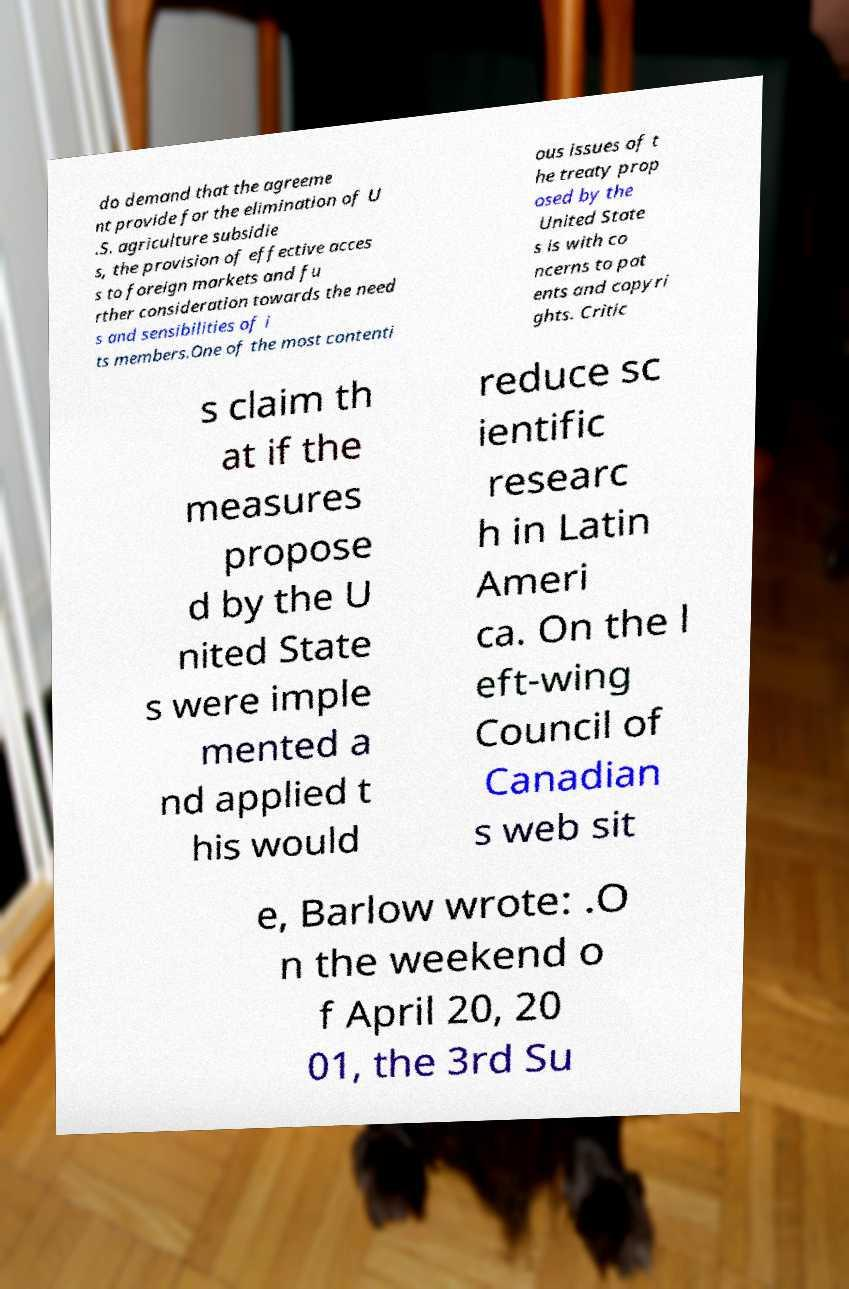Could you assist in decoding the text presented in this image and type it out clearly? do demand that the agreeme nt provide for the elimination of U .S. agriculture subsidie s, the provision of effective acces s to foreign markets and fu rther consideration towards the need s and sensibilities of i ts members.One of the most contenti ous issues of t he treaty prop osed by the United State s is with co ncerns to pat ents and copyri ghts. Critic s claim th at if the measures propose d by the U nited State s were imple mented a nd applied t his would reduce sc ientific researc h in Latin Ameri ca. On the l eft-wing Council of Canadian s web sit e, Barlow wrote: .O n the weekend o f April 20, 20 01, the 3rd Su 